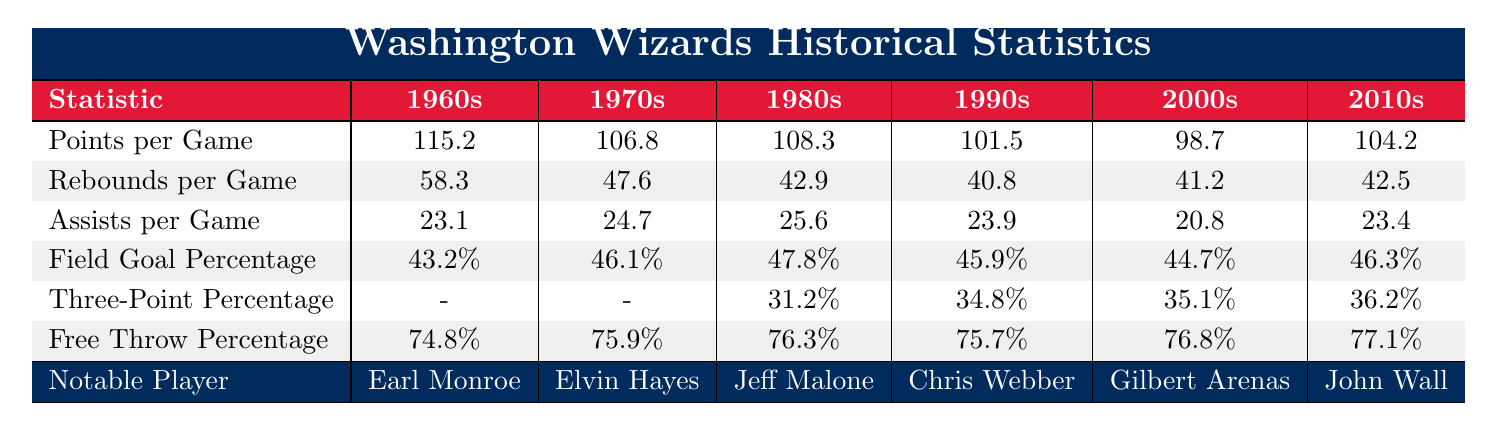What was the highest points per game recorded by the Washington Wizards in the 1960s? By looking at the table, the points per game for the 1960s is listed as 115.2, which is the highest value in that decade.
Answer: 115.2 Which decade had the lowest average rebounds per game? The rebounds per game values are 58.3, 47.6, 42.9, 40.8, 41.2, and 42.5 for the decades. The lowest value is 40.8 in the 1990s.
Answer: 1990s What was the free throw percentage for the Wizards in the 2000s? The free throw percentage for the 2000s is shown in the table as 76.8%.
Answer: 76.8% Did the Wizards' assists per game increase from the 1990s to the 2010s? The assists per game in the 1990s was 23.9, and in the 2010s it was 23.4. Since 23.4 is lower than 23.9, this indicates a decrease, thus the answer is no.
Answer: No What is the average field goal percentage across all decades for the Washington Wizards? To find the average, we add up all the values (43.2 + 46.1 + 47.8 + 45.9 + 44.7 + 46.3 = 273.0) and divide by the number of decades (273.0/6 = 45.5).
Answer: 45.5 In which decade did the Wizards have the lowest field goal percentage? Looking at the field goal percentage values, they are 43.2%, 46.1%, 47.8%, 45.9%, 44.7%, and 46.3%. The lowest value is 43.2%, which belongs to the 1960s.
Answer: 1960s What can be said about the trend in three-point percentage from the 1980s to the 2010s? The three-point percentages are 31.2% in the 1980s, 34.8% in the 1990s, 35.1% in the 2000s, and 36.2% in the 2010s. Observing these values shows a consistent increase over the decades.
Answer: Increasing Which player represented the Wizards in the 1980s? According to the notable players row, Jeff Malone is listed as the notable player for the 1980s.
Answer: Jeff Malone What was the change in rebounds per game from the 1970s to the 2000s? The rebounds per game in the 1970s was 47.6 and in the 2000s it was 41.2. The change is calculated as 47.6 - 41.2 = 6.4, indicating a decrease.
Answer: Decrease of 6.4 Which decade had the highest assists per game and what was the value? The assists per game across decades were 23.1, 24.7, 25.6, 23.9, 20.8, and 23.4. The highest is 25.6 in the 1980s.
Answer: 25.6 in the 1980s 